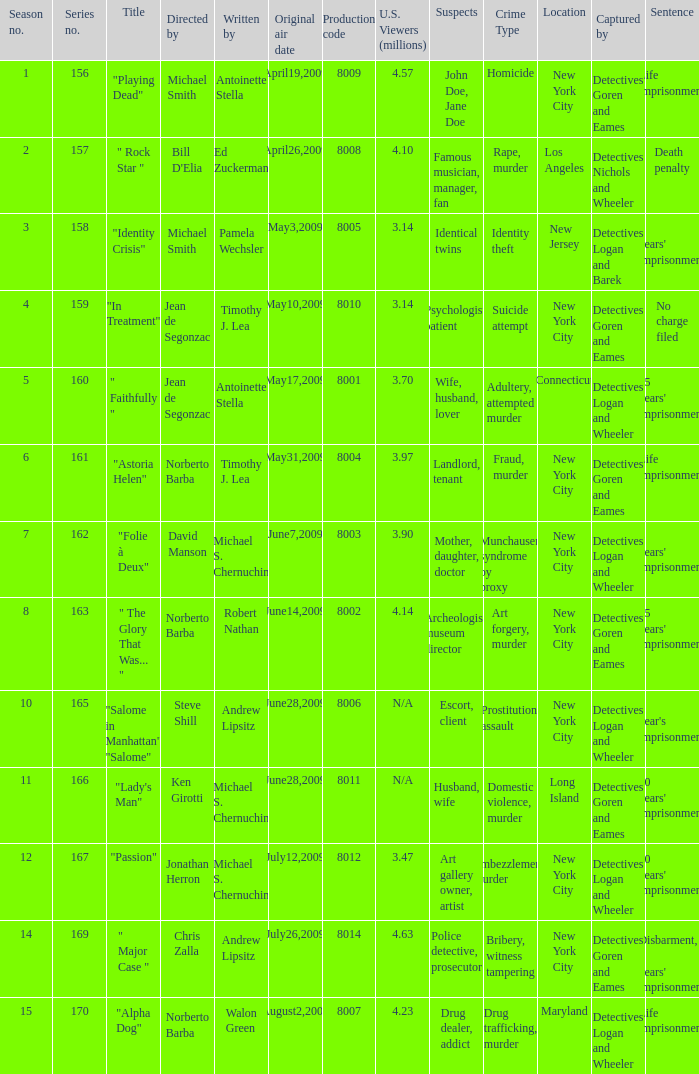What is the name of the episode whose writer is timothy j. lea and the director is norberto barba? "Astoria Helen". 